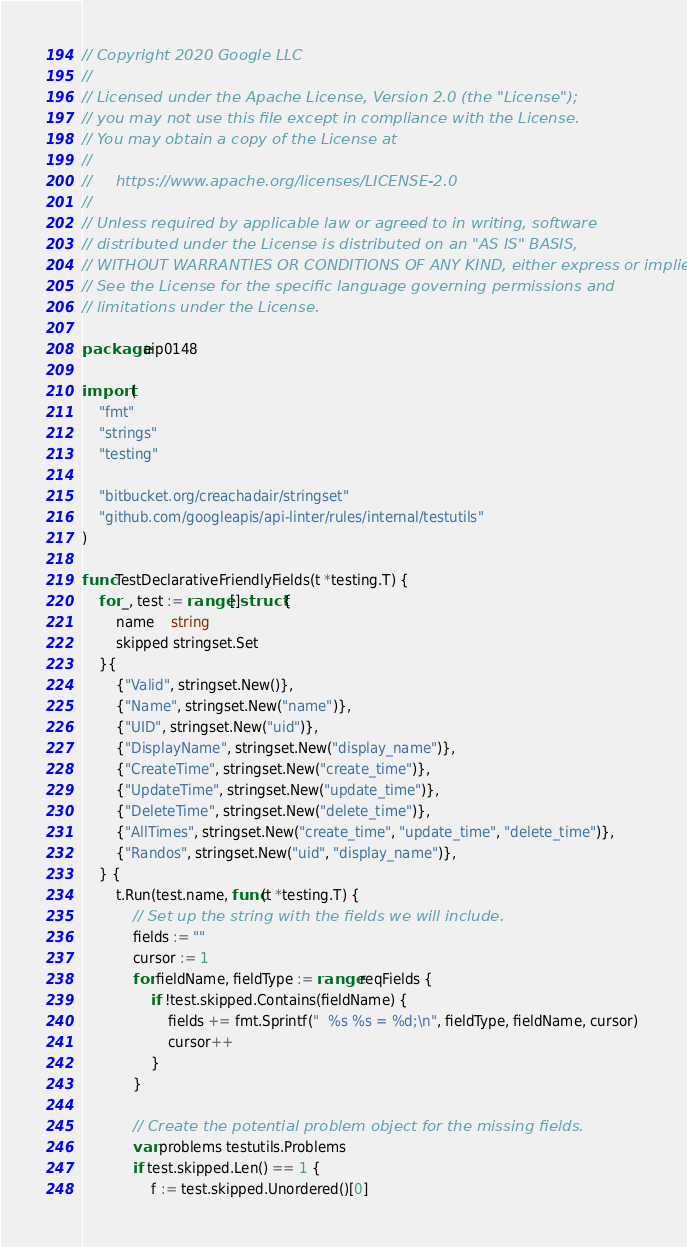Convert code to text. <code><loc_0><loc_0><loc_500><loc_500><_Go_>// Copyright 2020 Google LLC
//
// Licensed under the Apache License, Version 2.0 (the "License");
// you may not use this file except in compliance with the License.
// You may obtain a copy of the License at
//
//     https://www.apache.org/licenses/LICENSE-2.0
//
// Unless required by applicable law or agreed to in writing, software
// distributed under the License is distributed on an "AS IS" BASIS,
// WITHOUT WARRANTIES OR CONDITIONS OF ANY KIND, either express or implied.
// See the License for the specific language governing permissions and
// limitations under the License.

package aip0148

import (
	"fmt"
	"strings"
	"testing"

	"bitbucket.org/creachadair/stringset"
	"github.com/googleapis/api-linter/rules/internal/testutils"
)

func TestDeclarativeFriendlyFields(t *testing.T) {
	for _, test := range []struct {
		name    string
		skipped stringset.Set
	}{
		{"Valid", stringset.New()},
		{"Name", stringset.New("name")},
		{"UID", stringset.New("uid")},
		{"DisplayName", stringset.New("display_name")},
		{"CreateTime", stringset.New("create_time")},
		{"UpdateTime", stringset.New("update_time")},
		{"DeleteTime", stringset.New("delete_time")},
		{"AllTimes", stringset.New("create_time", "update_time", "delete_time")},
		{"Randos", stringset.New("uid", "display_name")},
	} {
		t.Run(test.name, func(t *testing.T) {
			// Set up the string with the fields we will include.
			fields := ""
			cursor := 1
			for fieldName, fieldType := range reqFields {
				if !test.skipped.Contains(fieldName) {
					fields += fmt.Sprintf("  %s %s = %d;\n", fieldType, fieldName, cursor)
					cursor++
				}
			}

			// Create the potential problem object for the missing fields.
			var problems testutils.Problems
			if test.skipped.Len() == 1 {
				f := test.skipped.Unordered()[0]</code> 